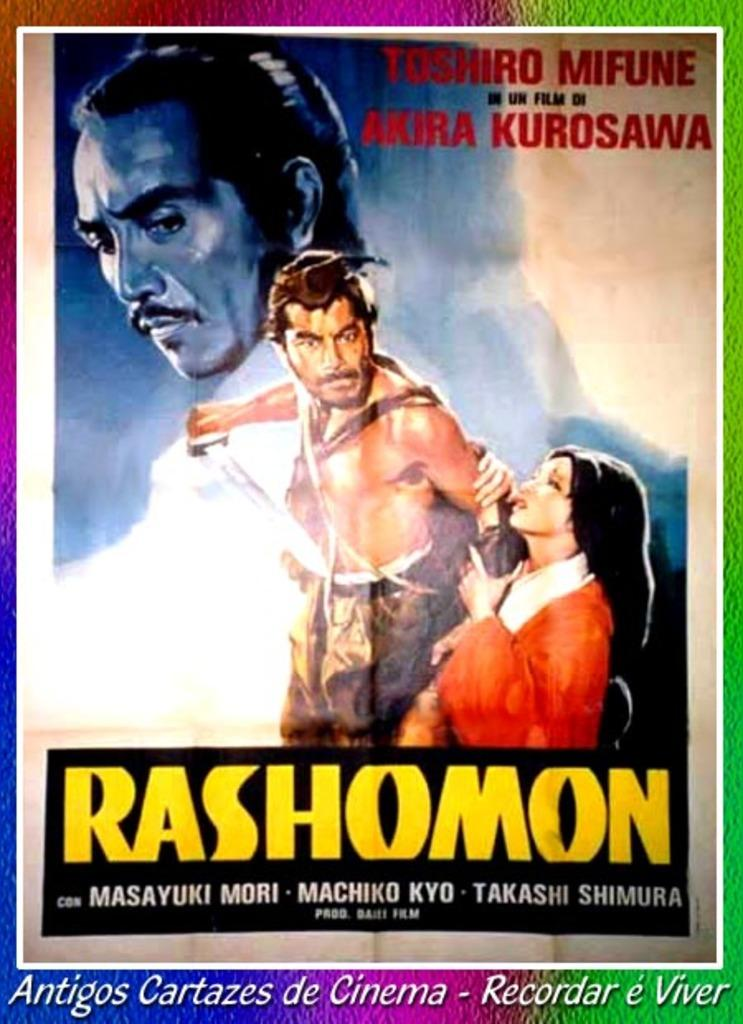<image>
Give a short and clear explanation of the subsequent image. Radhomon is playing at Antgos Cartazes de Cinema. 